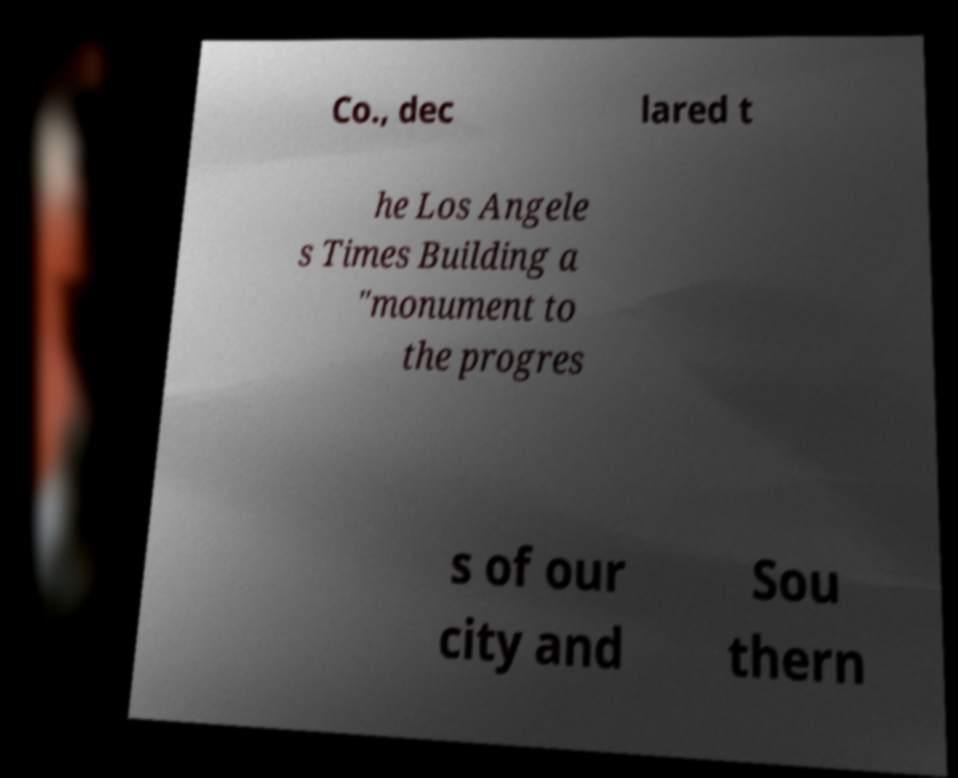Can you read and provide the text displayed in the image?This photo seems to have some interesting text. Can you extract and type it out for me? Co., dec lared t he Los Angele s Times Building a "monument to the progres s of our city and Sou thern 